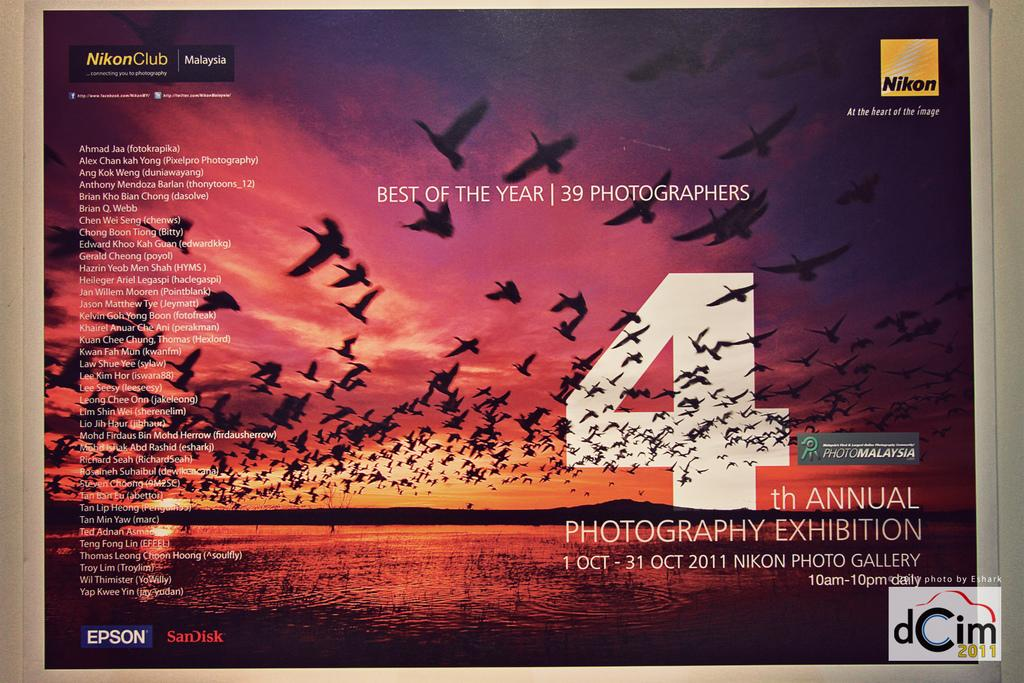<image>
Provide a brief description of the given image. A poster advertising the best photos of the year saying it is the fourth annual. 